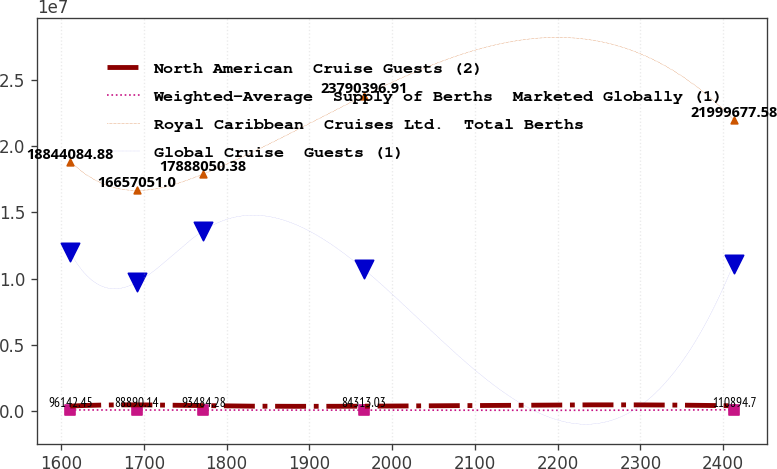<chart> <loc_0><loc_0><loc_500><loc_500><line_chart><ecel><fcel>North American  Cruise Guests (2)<fcel>Weighted-Average  Supply of Berths  Marketed Globally (1)<fcel>Royal Caribbean  Cruises Ltd.  Total Berths<fcel>Global Cruise  Guests (1)<nl><fcel>1611.1<fcel>388724<fcel>96142.4<fcel>1.88441e+07<fcel>1.19874e+07<nl><fcel>1691.26<fcel>478573<fcel>88890.1<fcel>1.66571e+07<fcel>9.71459e+06<nl><fcel>1771.42<fcel>417093<fcel>93484.3<fcel>1.78881e+07<fcel>1.36051e+07<nl><fcel>1965.52<fcel>378741<fcel>84313<fcel>2.37904e+07<fcel>1.07361e+07<nl><fcel>2412.72<fcel>407110<fcel>110895<fcel>2.19997e+07<fcel>1.11252e+07<nl></chart> 